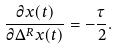Convert formula to latex. <formula><loc_0><loc_0><loc_500><loc_500>\frac { \partial x ( t ) } { \partial \Delta ^ { R } x ( t ) } = - \frac { \tau } { 2 } .</formula> 